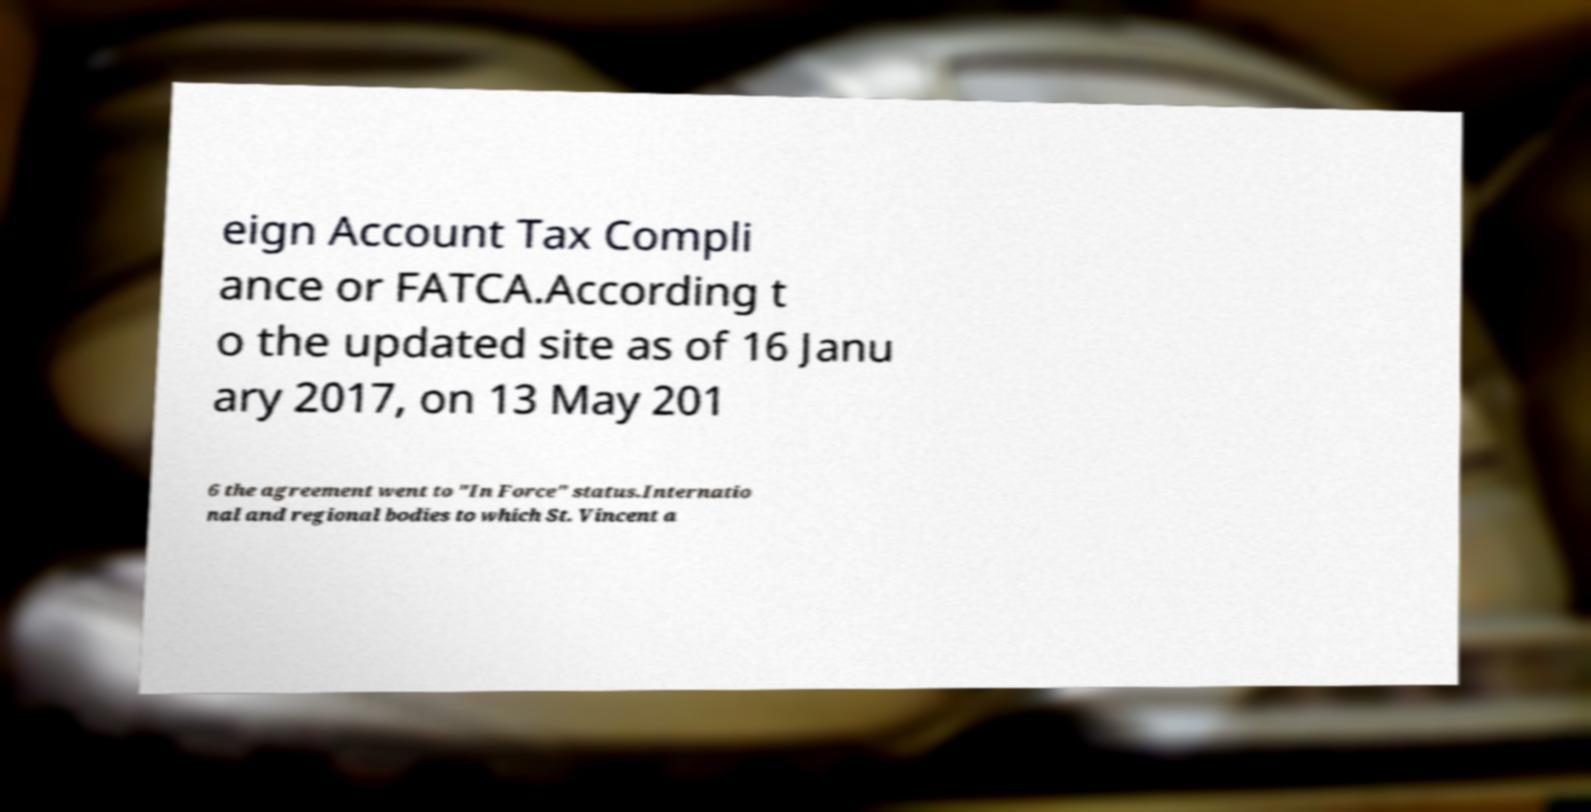I need the written content from this picture converted into text. Can you do that? eign Account Tax Compli ance or FATCA.According t o the updated site as of 16 Janu ary 2017, on 13 May 201 6 the agreement went to "In Force" status.Internatio nal and regional bodies to which St. Vincent a 